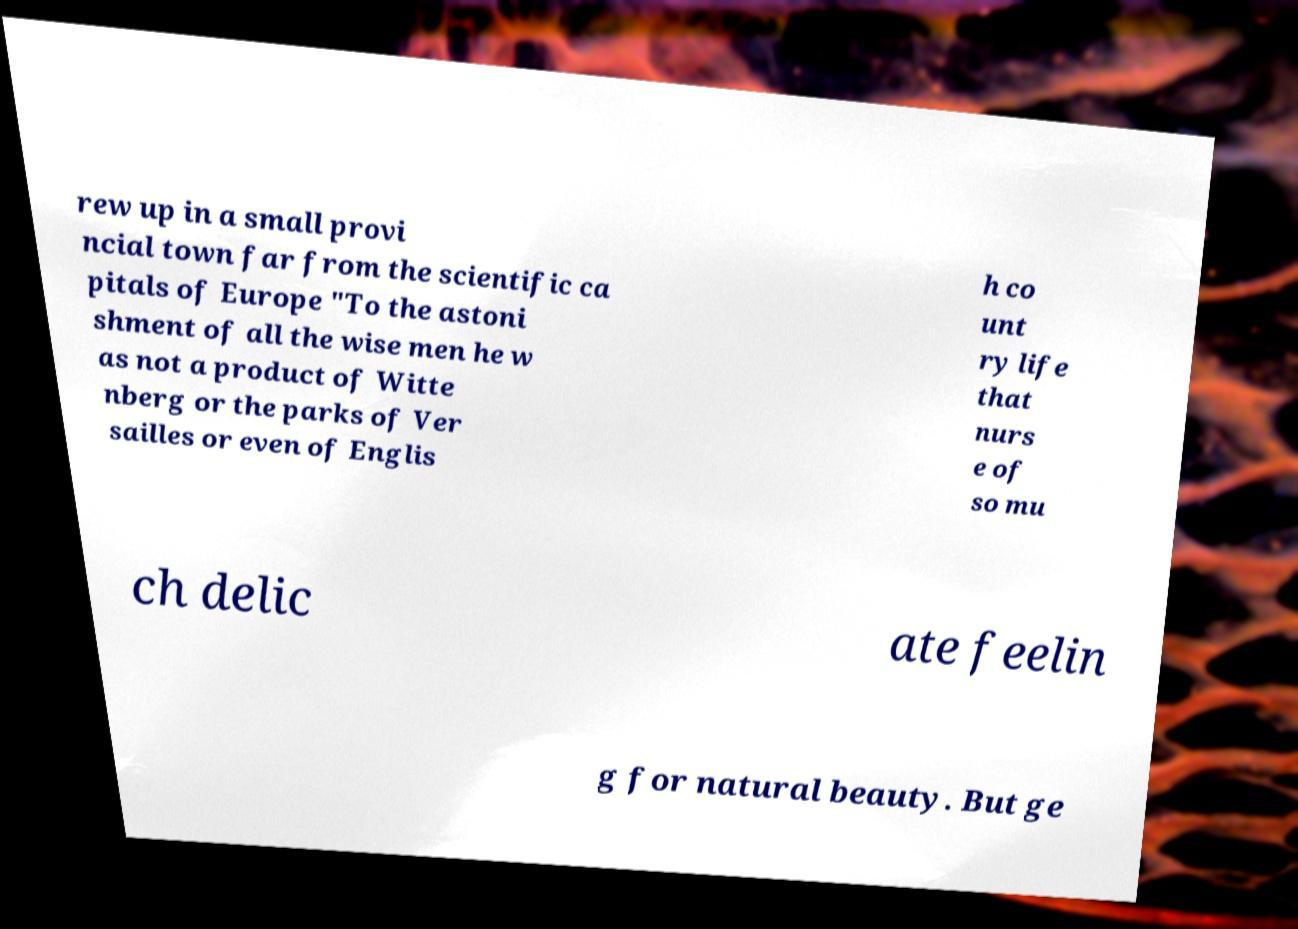What messages or text are displayed in this image? I need them in a readable, typed format. rew up in a small provi ncial town far from the scientific ca pitals of Europe "To the astoni shment of all the wise men he w as not a product of Witte nberg or the parks of Ver sailles or even of Englis h co unt ry life that nurs e of so mu ch delic ate feelin g for natural beauty. But ge 